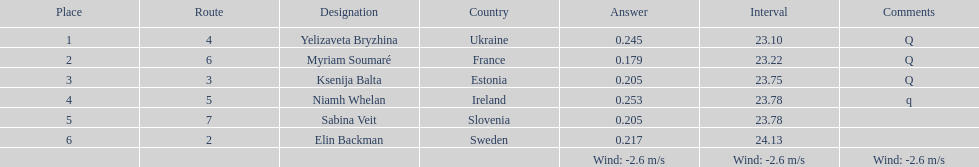What count of last names initiate with "b"? 3. Would you mind parsing the complete table? {'header': ['Place', 'Route', 'Designation', 'Country', 'Answer', 'Interval', 'Comments'], 'rows': [['1', '4', 'Yelizaveta Bryzhina', 'Ukraine', '0.245', '23.10', 'Q'], ['2', '6', 'Myriam Soumaré', 'France', '0.179', '23.22', 'Q'], ['3', '3', 'Ksenija Balta', 'Estonia', '0.205', '23.75', 'Q'], ['4', '5', 'Niamh Whelan', 'Ireland', '0.253', '23.78', 'q'], ['5', '7', 'Sabina Veit', 'Slovenia', '0.205', '23.78', ''], ['6', '2', 'Elin Backman', 'Sweden', '0.217', '24.13', ''], ['', '', '', '', 'Wind: -2.6\xa0m/s', 'Wind: -2.6\xa0m/s', 'Wind: -2.6\xa0m/s']]} 